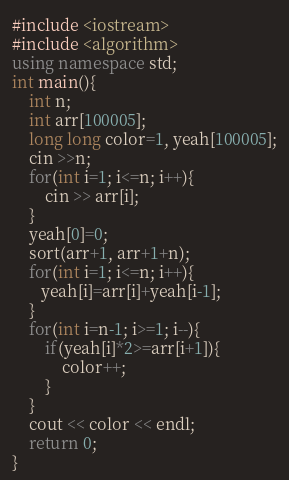<code> <loc_0><loc_0><loc_500><loc_500><_C++_>#include <iostream> 
#include <algorithm>
using namespace std;
int main(){
    int n;
    int arr[100005];
    long long color=1, yeah[100005];
    cin >>n;
    for(int i=1; i<=n; i++){
        cin >> arr[i];
    }
    yeah[0]=0;
    sort(arr+1, arr+1+n);
    for(int i=1; i<=n; i++){
       yeah[i]=arr[i]+yeah[i-1];
    }
    for(int i=n-1; i>=1; i--){
        if(yeah[i]*2>=arr[i+1]){
            color++;
        }
    }
    cout << color << endl;
    return 0;
}</code> 